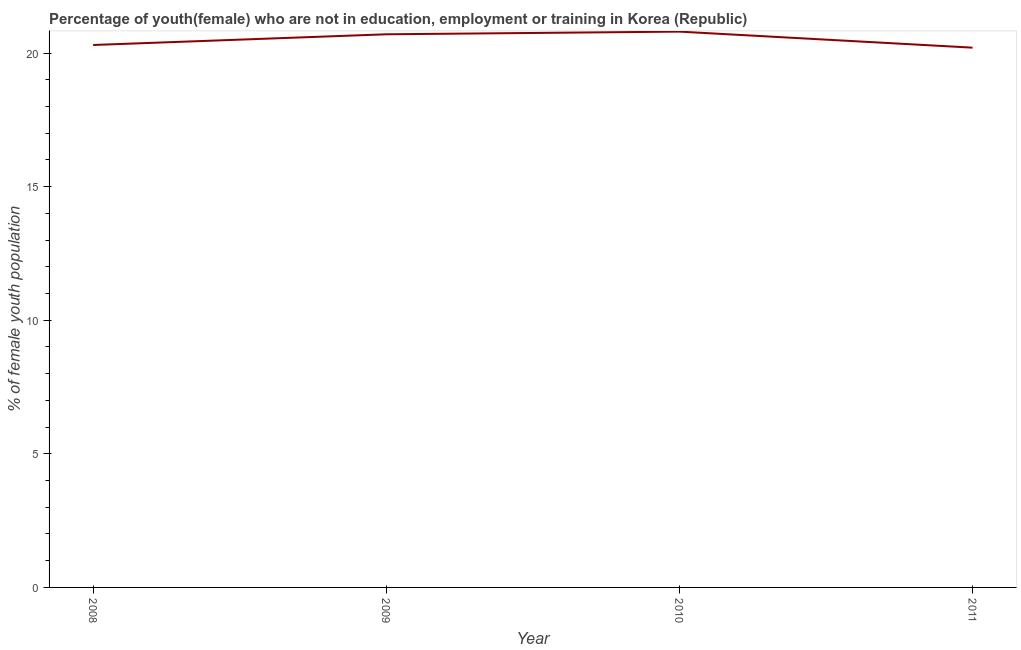What is the unemployed female youth population in 2009?
Keep it short and to the point. 20.7. Across all years, what is the maximum unemployed female youth population?
Offer a very short reply. 20.8. Across all years, what is the minimum unemployed female youth population?
Your answer should be very brief. 20.2. What is the median unemployed female youth population?
Your answer should be very brief. 20.5. In how many years, is the unemployed female youth population greater than 7 %?
Keep it short and to the point. 4. What is the ratio of the unemployed female youth population in 2008 to that in 2009?
Offer a terse response. 0.98. Is the difference between the unemployed female youth population in 2010 and 2011 greater than the difference between any two years?
Keep it short and to the point. Yes. What is the difference between the highest and the second highest unemployed female youth population?
Your answer should be very brief. 0.1. What is the difference between the highest and the lowest unemployed female youth population?
Offer a terse response. 0.6. In how many years, is the unemployed female youth population greater than the average unemployed female youth population taken over all years?
Make the answer very short. 2. Does the unemployed female youth population monotonically increase over the years?
Offer a very short reply. No. How many lines are there?
Your response must be concise. 1. What is the difference between two consecutive major ticks on the Y-axis?
Keep it short and to the point. 5. What is the title of the graph?
Make the answer very short. Percentage of youth(female) who are not in education, employment or training in Korea (Republic). What is the label or title of the X-axis?
Provide a short and direct response. Year. What is the label or title of the Y-axis?
Provide a short and direct response. % of female youth population. What is the % of female youth population of 2008?
Provide a short and direct response. 20.3. What is the % of female youth population in 2009?
Provide a succinct answer. 20.7. What is the % of female youth population in 2010?
Your answer should be very brief. 20.8. What is the % of female youth population of 2011?
Keep it short and to the point. 20.2. What is the difference between the % of female youth population in 2008 and 2010?
Ensure brevity in your answer.  -0.5. What is the difference between the % of female youth population in 2008 and 2011?
Provide a short and direct response. 0.1. What is the difference between the % of female youth population in 2009 and 2011?
Offer a very short reply. 0.5. What is the difference between the % of female youth population in 2010 and 2011?
Provide a short and direct response. 0.6. What is the ratio of the % of female youth population in 2008 to that in 2010?
Your answer should be very brief. 0.98. What is the ratio of the % of female youth population in 2008 to that in 2011?
Ensure brevity in your answer.  1. What is the ratio of the % of female youth population in 2010 to that in 2011?
Offer a very short reply. 1.03. 